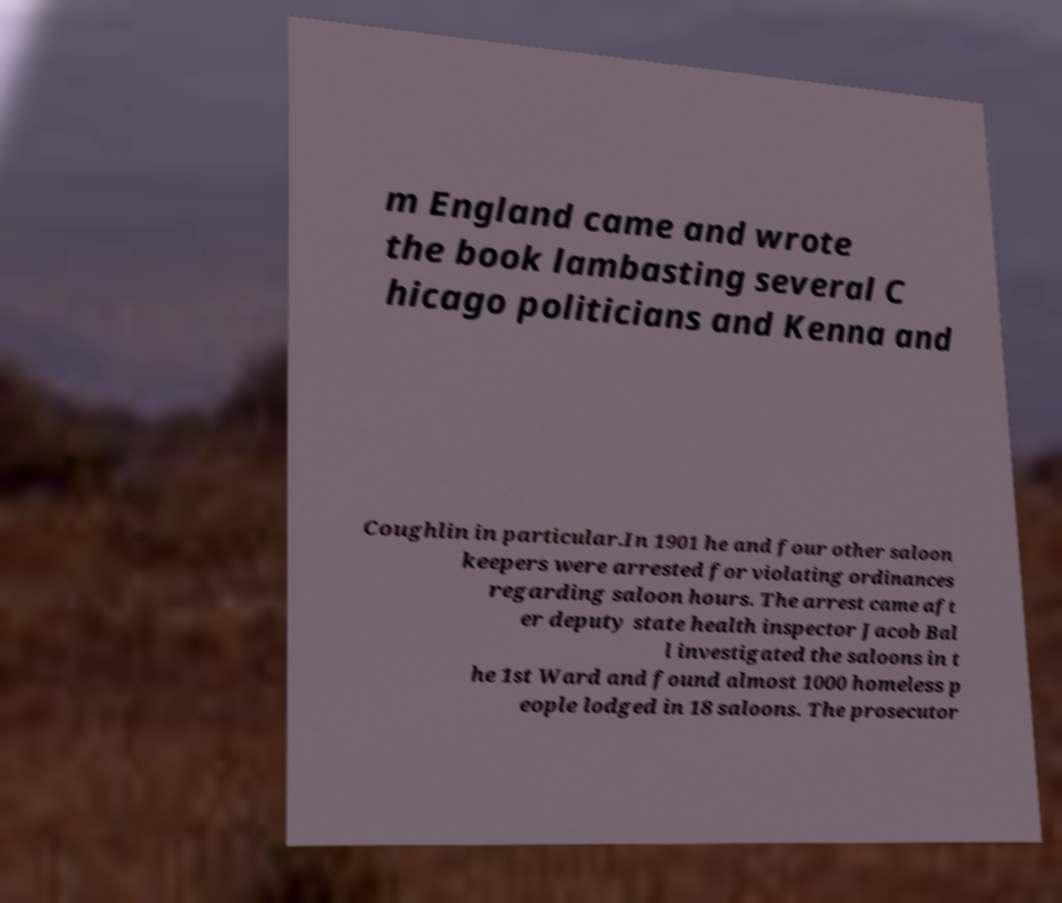For documentation purposes, I need the text within this image transcribed. Could you provide that? m England came and wrote the book lambasting several C hicago politicians and Kenna and Coughlin in particular.In 1901 he and four other saloon keepers were arrested for violating ordinances regarding saloon hours. The arrest came aft er deputy state health inspector Jacob Bal l investigated the saloons in t he 1st Ward and found almost 1000 homeless p eople lodged in 18 saloons. The prosecutor 